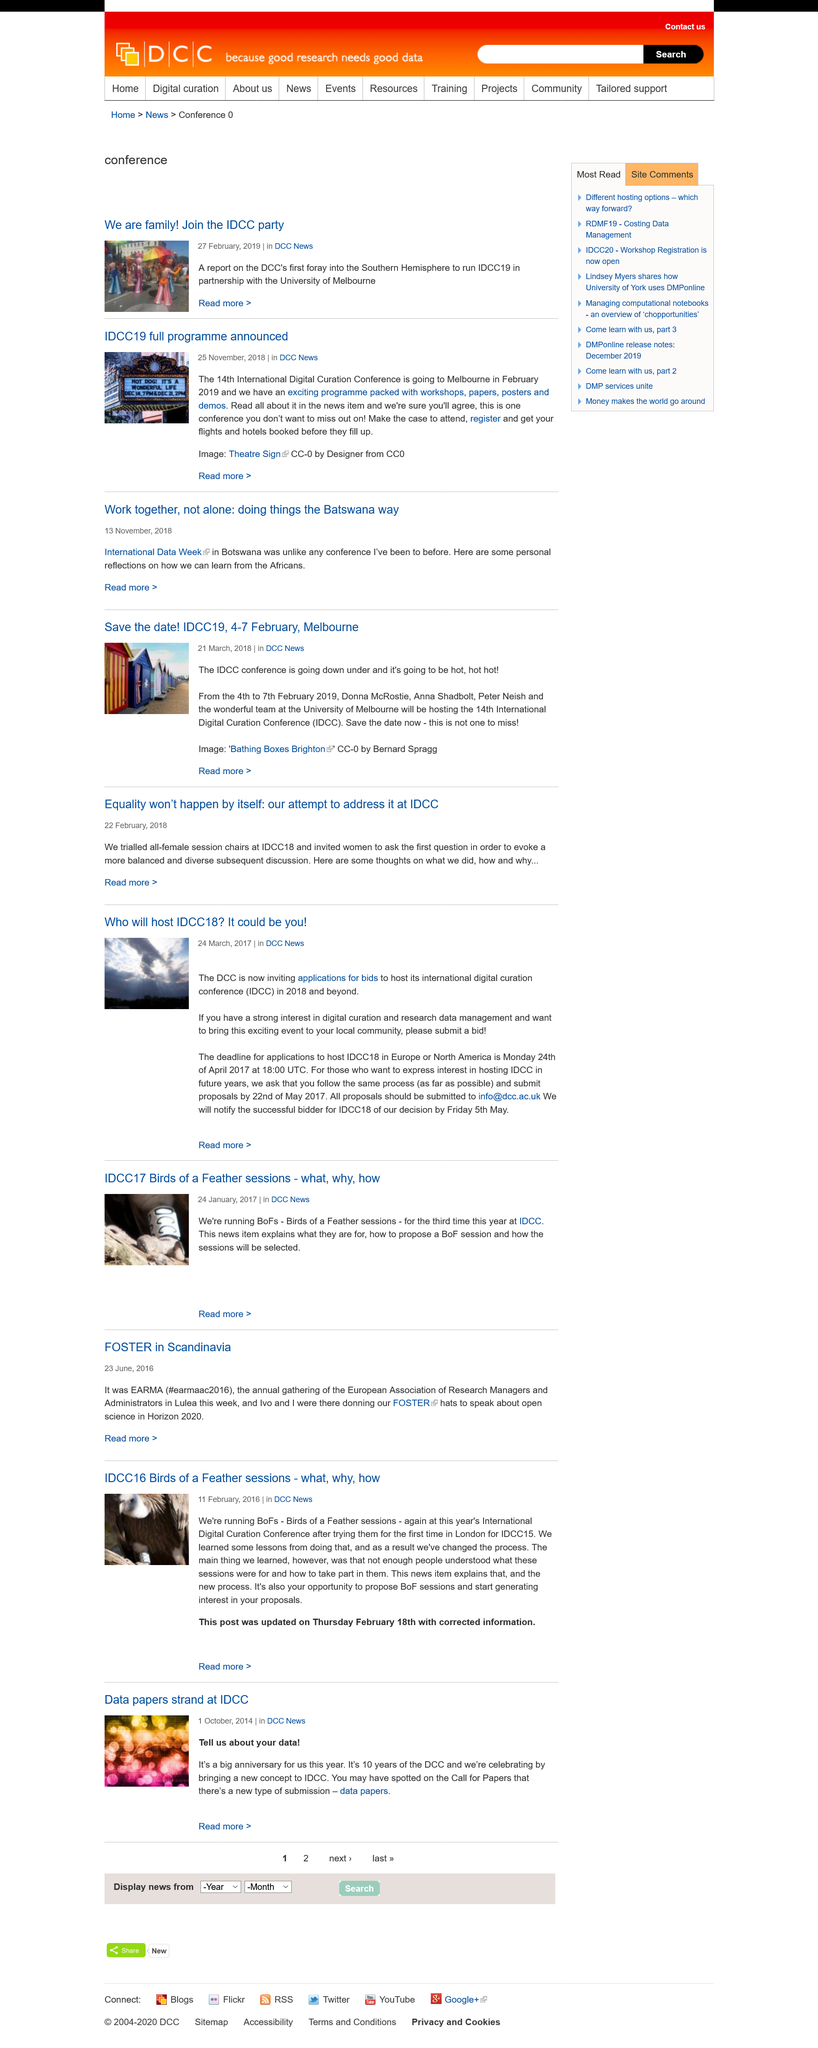Specify some key components in this picture. The article on "data paper strands" at IDCC was published on October 1, 2014. The main hosts at IDCC 19 will be Donna McRostie, Anna Shadbolt, and Peter Neish. At IDCC, we are holding Birds of a Feather sessions for the third time this year, and one of them is titled 'Bofs'. The venue for IDCC19 is the University of Melbourne. BoFs stands for Birds of a Feather sessions, which are informal gatherings of people with a common interest or goal, typically held at conferences or other events. 